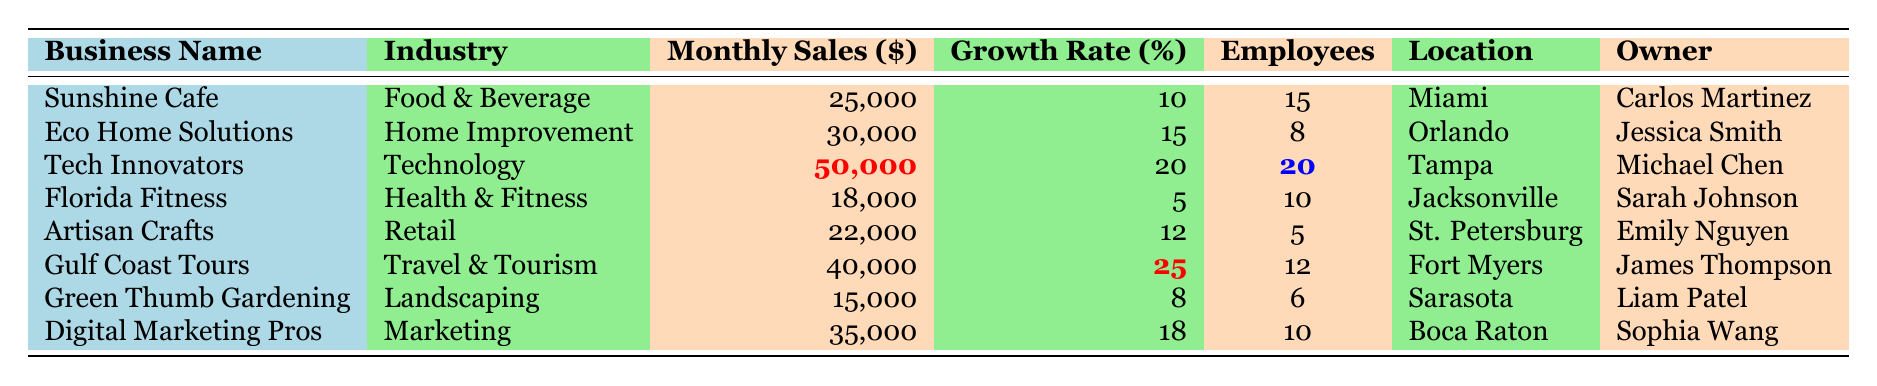What is the monthly sales amount for Tech Innovators? The table lists the monthly sales for Tech Innovators as $50,000 under the "Monthly Sales ($)" column.
Answer: $50,000 Which business has the highest annual growth rate? Looking through the "Growth Rate (%)" column, Gulf Coast Tours has the highest growth rate at 25%.
Answer: Gulf Coast Tours What is the total monthly sales for all businesses listed? Adding the monthly sales: \( 25000 + 30000 + 50000 + 18000 + 22000 + 40000 + 15000 + 35000 = 187000 \).
Answer: $187,000 How many employees does Digital Marketing Pros have? The table shows that Digital Marketing Pros has 10 employees listed in the "Employees" column.
Answer: 10 Is there a business with monthly sales less than $20,000? Yes, Florida Fitness has monthly sales of $18,000, which is less than $20,000, as indicated in the "Monthly Sales ($)" column.
Answer: Yes Which industry has the second highest monthly sales? After comparing the monthly sales amounts, Eco Home Solutions comes second with $30,000 after Tech Innovators with $50,000.
Answer: Home Improvement What is the average number of employees across all businesses? Summing the employees gives \( 15 + 8 + 20 + 10 + 5 + 12 + 6 + 10 = 86 \). The average is \( 86/8 = 10.75 \), so rounding gives approximately 11 employees.
Answer: 11 Which location has the least monthly sales? Green Thumb Gardening, located in Sarasota, has the lowest monthly sales at $15,000, compared to others in the "Monthly Sales ($)" column.
Answer: Sarasota How many businesses have an annual growth rate greater than 15%? Examining the "Growth Rate (%)" column, Tech Innovators (20%), Eco Home Solutions (15%), and Gulf Coast Tours (25%) are the qualifying businesses. Thus, there are 2 businesses over 15%.
Answer: 2 What is the combined monthly sales of businesses in the Food & Beverage and Health & Fitness industries? Adding the monthly sales for Sunshine Cafe ($25,000) and Florida Fitness ($18,000), we find that the combined total is \( 25000 + 18000 = 43000 \).
Answer: $43,000 